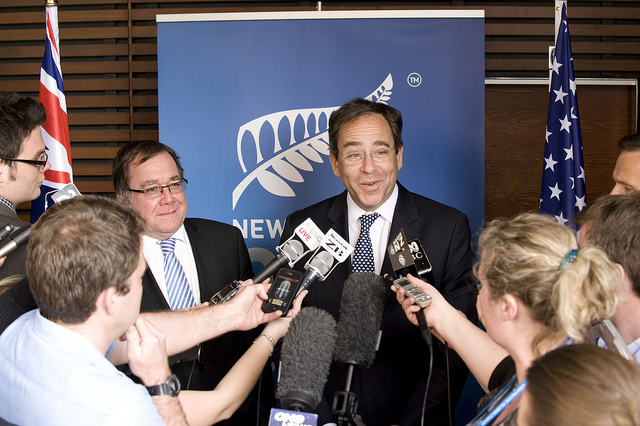Please transcribe the text information in this image. EW LIVE ANZ 